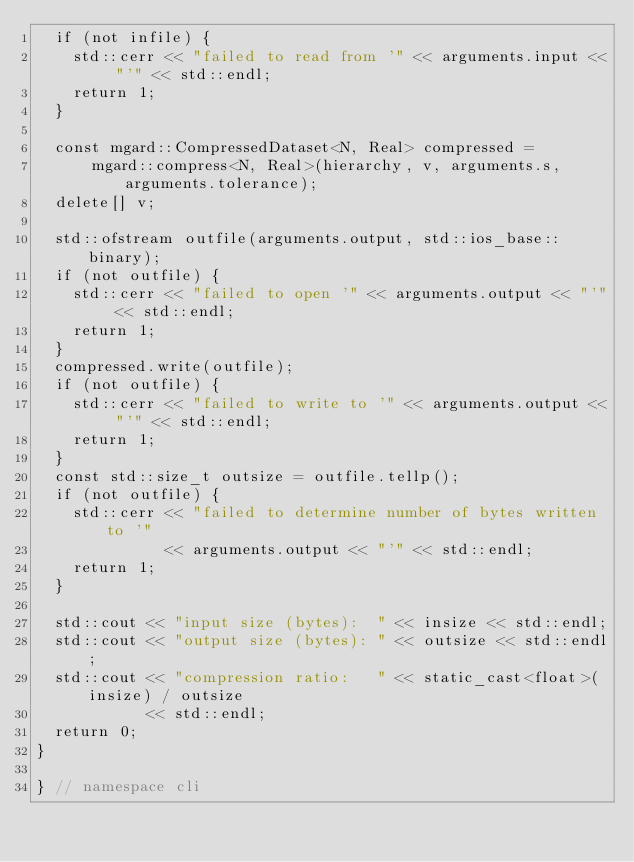<code> <loc_0><loc_0><loc_500><loc_500><_C++_>  if (not infile) {
    std::cerr << "failed to read from '" << arguments.input << "'" << std::endl;
    return 1;
  }

  const mgard::CompressedDataset<N, Real> compressed =
      mgard::compress<N, Real>(hierarchy, v, arguments.s, arguments.tolerance);
  delete[] v;

  std::ofstream outfile(arguments.output, std::ios_base::binary);
  if (not outfile) {
    std::cerr << "failed to open '" << arguments.output << "'" << std::endl;
    return 1;
  }
  compressed.write(outfile);
  if (not outfile) {
    std::cerr << "failed to write to '" << arguments.output << "'" << std::endl;
    return 1;
  }
  const std::size_t outsize = outfile.tellp();
  if (not outfile) {
    std::cerr << "failed to determine number of bytes written to '"
              << arguments.output << "'" << std::endl;
    return 1;
  }

  std::cout << "input size (bytes):  " << insize << std::endl;
  std::cout << "output size (bytes): " << outsize << std::endl;
  std::cout << "compression ratio:   " << static_cast<float>(insize) / outsize
            << std::endl;
  return 0;
}

} // namespace cli
</code> 